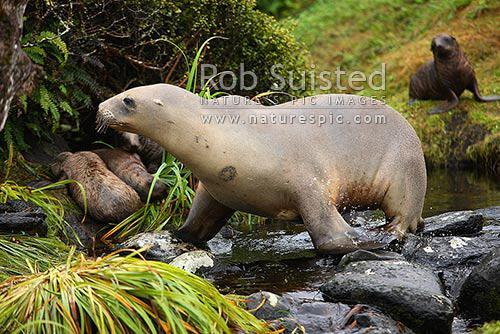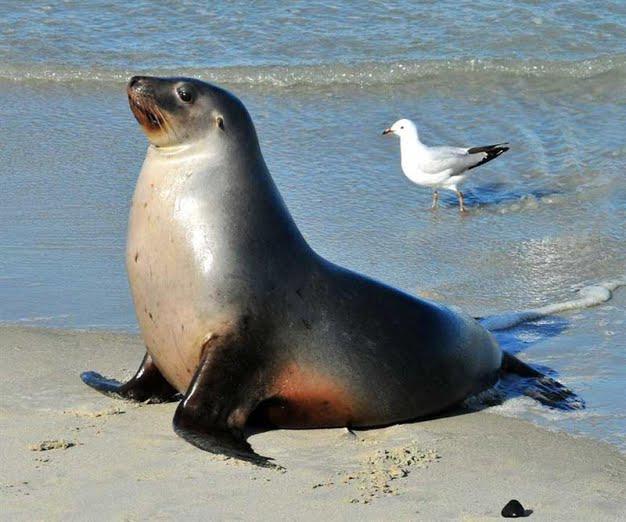The first image is the image on the left, the second image is the image on the right. Analyze the images presented: Is the assertion "The right image contains exactly two seals." valid? Answer yes or no. No. The first image is the image on the left, the second image is the image on the right. For the images shown, is this caption "There are four sea lions in the image pair." true? Answer yes or no. No. 